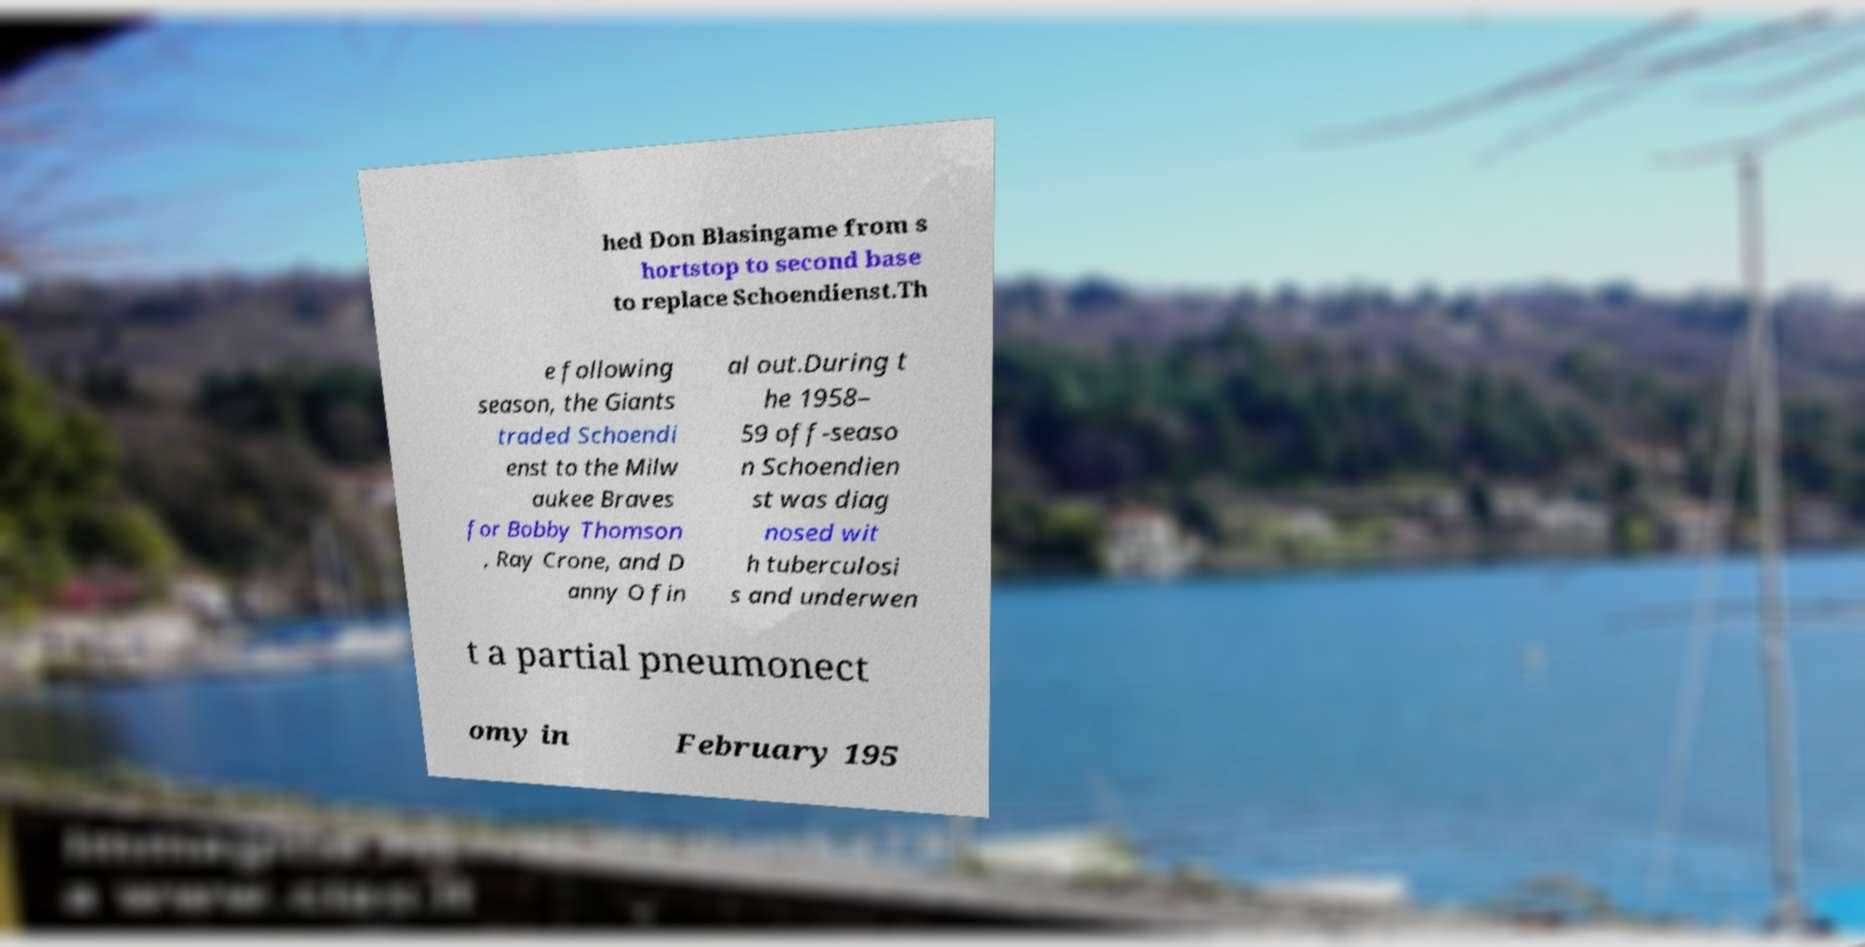Could you assist in decoding the text presented in this image and type it out clearly? hed Don Blasingame from s hortstop to second base to replace Schoendienst.Th e following season, the Giants traded Schoendi enst to the Milw aukee Braves for Bobby Thomson , Ray Crone, and D anny O fin al out.During t he 1958– 59 off-seaso n Schoendien st was diag nosed wit h tuberculosi s and underwen t a partial pneumonect omy in February 195 